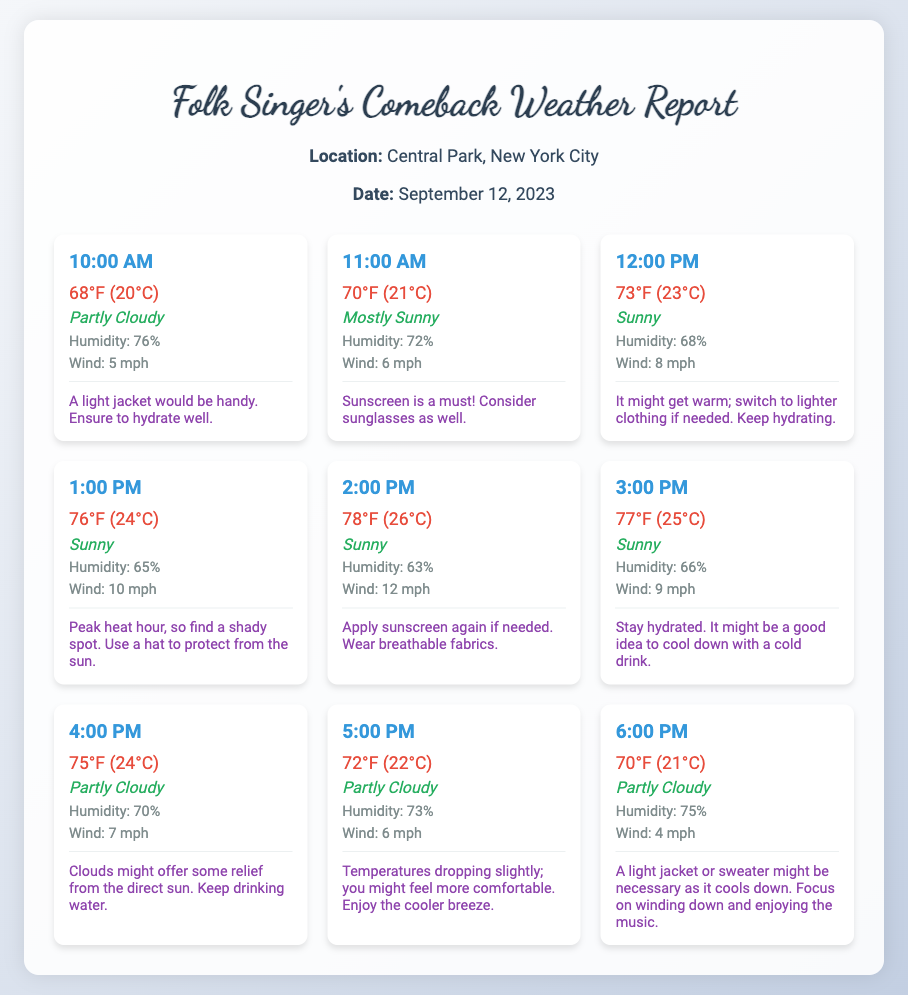what is the date of the performance? The date is specified in the header section of the document.
Answer: September 12, 2023 what is the location of the performance? The location is mentioned at the top of the document.
Answer: Central Park, New York City what time does the weather report start? The first time listed in the weather breakdown is considered the start time.
Answer: 10:00 AM what is the humidity at 1:00 PM? The humidity is specifically mentioned for that hour within the weather cards.
Answer: 65% what is the temperature at 3:00 PM? The temperature is displayed in the weather card for that hour.
Answer: 77°F (25°C) how many degrees warmer is it at 2:00 PM compared to 10:00 AM? The temperatures at both hours must be compared: 78°F (26°C) at 2:00 PM and 68°F (20°C) at 10:00 AM.
Answer: 10°F what is a recommended tip for 12:00 PM? The tips for each hour provide advice tailored to the weather conditions.
Answer: Switch to lighter clothing if needed. Keep hydrating at what time does the temperature start to drop? The temperatures in the weather report will show a shift after this specified hour.
Answer: 5:00 PM what is the weather condition at 6:00 PM? The weather condition is clearly stated in the weather card for that hour.
Answer: Partly Cloudy 